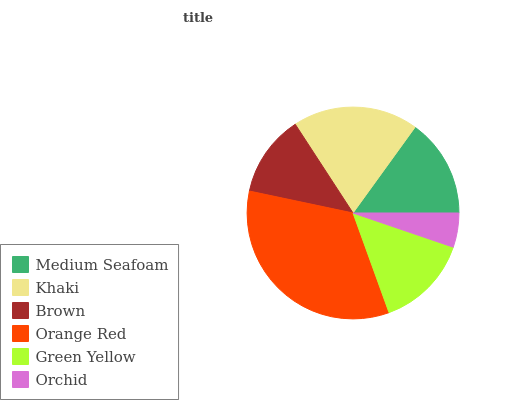Is Orchid the minimum?
Answer yes or no. Yes. Is Orange Red the maximum?
Answer yes or no. Yes. Is Khaki the minimum?
Answer yes or no. No. Is Khaki the maximum?
Answer yes or no. No. Is Khaki greater than Medium Seafoam?
Answer yes or no. Yes. Is Medium Seafoam less than Khaki?
Answer yes or no. Yes. Is Medium Seafoam greater than Khaki?
Answer yes or no. No. Is Khaki less than Medium Seafoam?
Answer yes or no. No. Is Medium Seafoam the high median?
Answer yes or no. Yes. Is Green Yellow the low median?
Answer yes or no. Yes. Is Orange Red the high median?
Answer yes or no. No. Is Brown the low median?
Answer yes or no. No. 